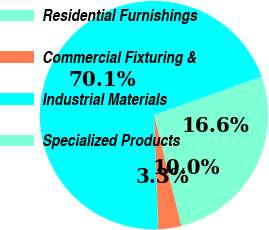Convert chart to OTSL. <chart><loc_0><loc_0><loc_500><loc_500><pie_chart><fcel>Residential Furnishings<fcel>Commercial Fixturing &<fcel>Industrial Materials<fcel>Specialized Products<nl><fcel>9.96%<fcel>3.28%<fcel>70.11%<fcel>16.65%<nl></chart> 